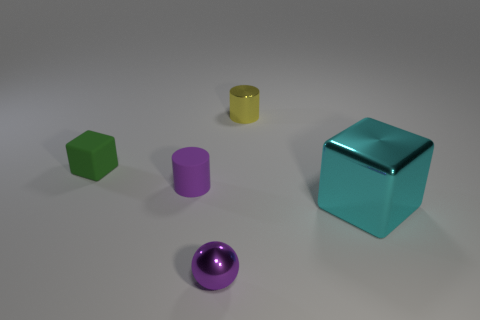Are the shadows consistent with a single light source? Yes, the shadows are consistent with a single light source. They fall in the same general direction and display appropriate variations in length and darkness for each object. 